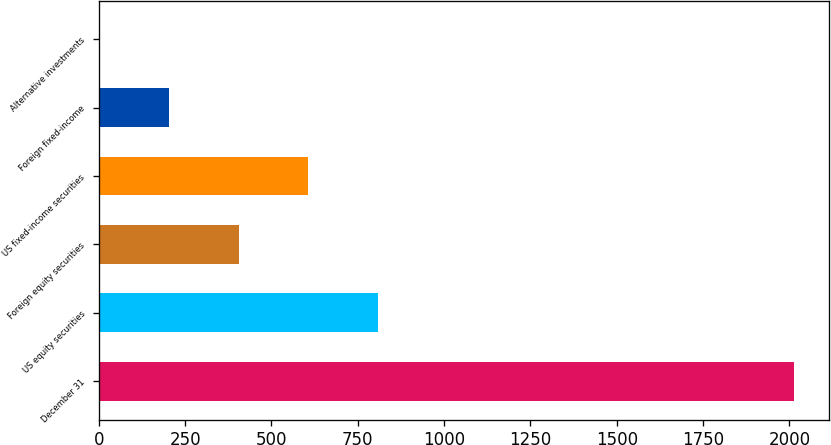Convert chart to OTSL. <chart><loc_0><loc_0><loc_500><loc_500><bar_chart><fcel>December 31<fcel>US equity securities<fcel>Foreign equity securities<fcel>US fixed-income securities<fcel>Foreign fixed-income<fcel>Alternative investments<nl><fcel>2014<fcel>807.4<fcel>405.2<fcel>606.3<fcel>204.1<fcel>3<nl></chart> 